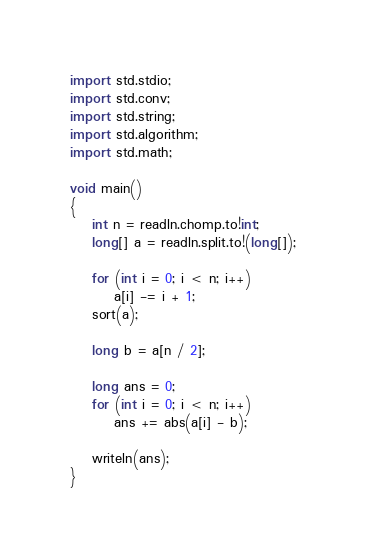<code> <loc_0><loc_0><loc_500><loc_500><_D_>import std.stdio;
import std.conv;
import std.string;
import std.algorithm;
import std.math;

void main()
{
    int n = readln.chomp.to!int;
    long[] a = readln.split.to!(long[]);

    for (int i = 0; i < n; i++)
        a[i] -= i + 1;
    sort(a);

    long b = a[n / 2];

    long ans = 0;
    for (int i = 0; i < n; i++)
        ans += abs(a[i] - b);

    writeln(ans);
}</code> 